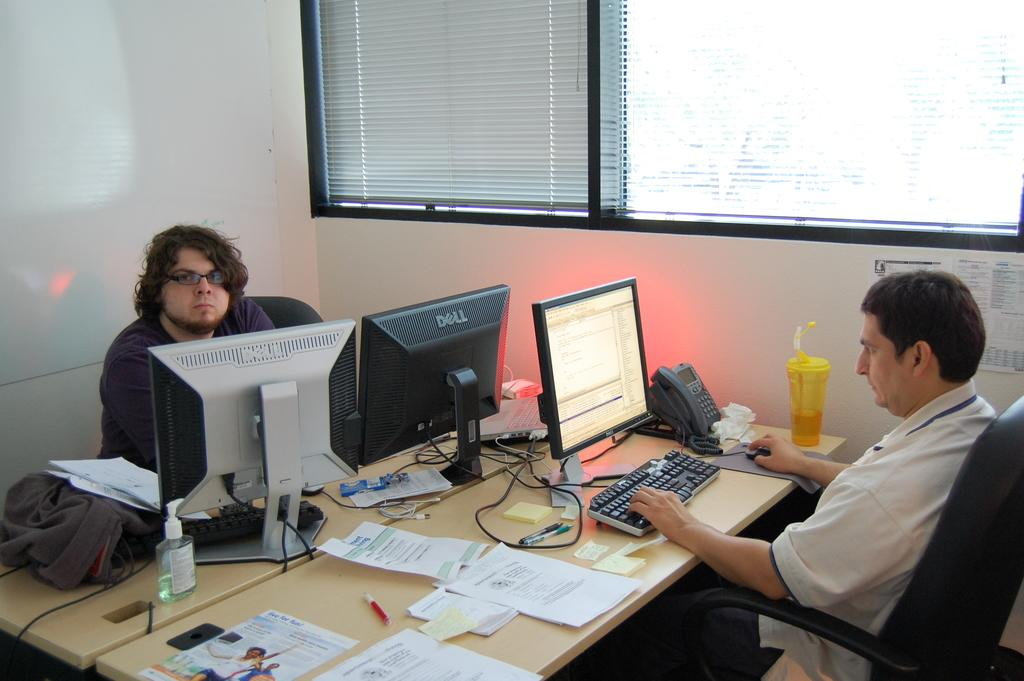Provide a one-sentence caption for the provided image. A man works at a desk in front of two Dell monitors. 